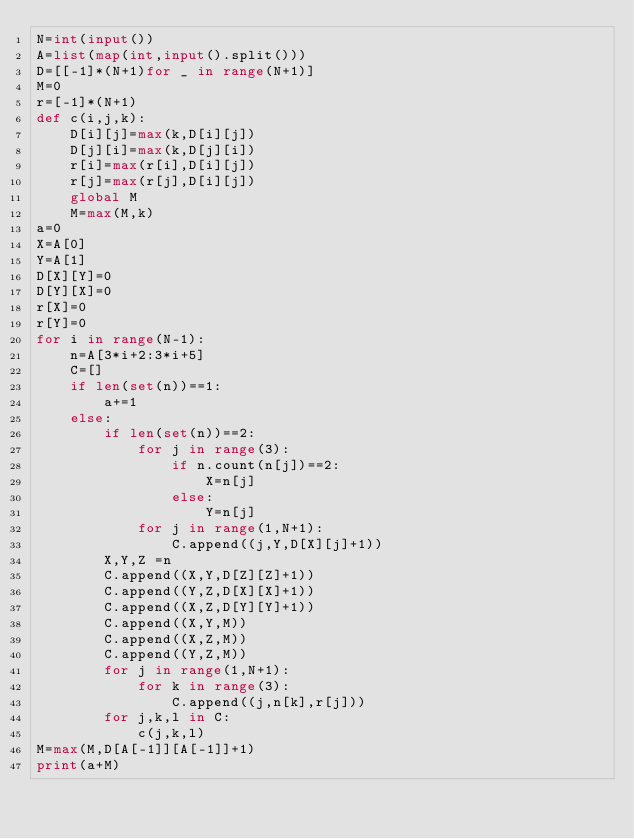Convert code to text. <code><loc_0><loc_0><loc_500><loc_500><_Python_>N=int(input())
A=list(map(int,input().split()))
D=[[-1]*(N+1)for _ in range(N+1)]
M=0
r=[-1]*(N+1)
def c(i,j,k):
    D[i][j]=max(k,D[i][j])
    D[j][i]=max(k,D[j][i])
    r[i]=max(r[i],D[i][j])
    r[j]=max(r[j],D[i][j])
    global M
    M=max(M,k)
a=0
X=A[0]
Y=A[1]
D[X][Y]=0
D[Y][X]=0
r[X]=0
r[Y]=0
for i in range(N-1):
    n=A[3*i+2:3*i+5]
    C=[]
    if len(set(n))==1:
        a+=1
    else:
        if len(set(n))==2:
            for j in range(3):
                if n.count(n[j])==2:
                    X=n[j]
                else:
                    Y=n[j]
            for j in range(1,N+1):
                C.append((j,Y,D[X][j]+1))
        X,Y,Z =n
        C.append((X,Y,D[Z][Z]+1))
        C.append((Y,Z,D[X][X]+1))
        C.append((X,Z,D[Y][Y]+1))
        C.append((X,Y,M))
        C.append((X,Z,M))
        C.append((Y,Z,M))
        for j in range(1,N+1):
            for k in range(3):
                C.append((j,n[k],r[j]))
        for j,k,l in C:
            c(j,k,l)
M=max(M,D[A[-1]][A[-1]]+1)
print(a+M)</code> 